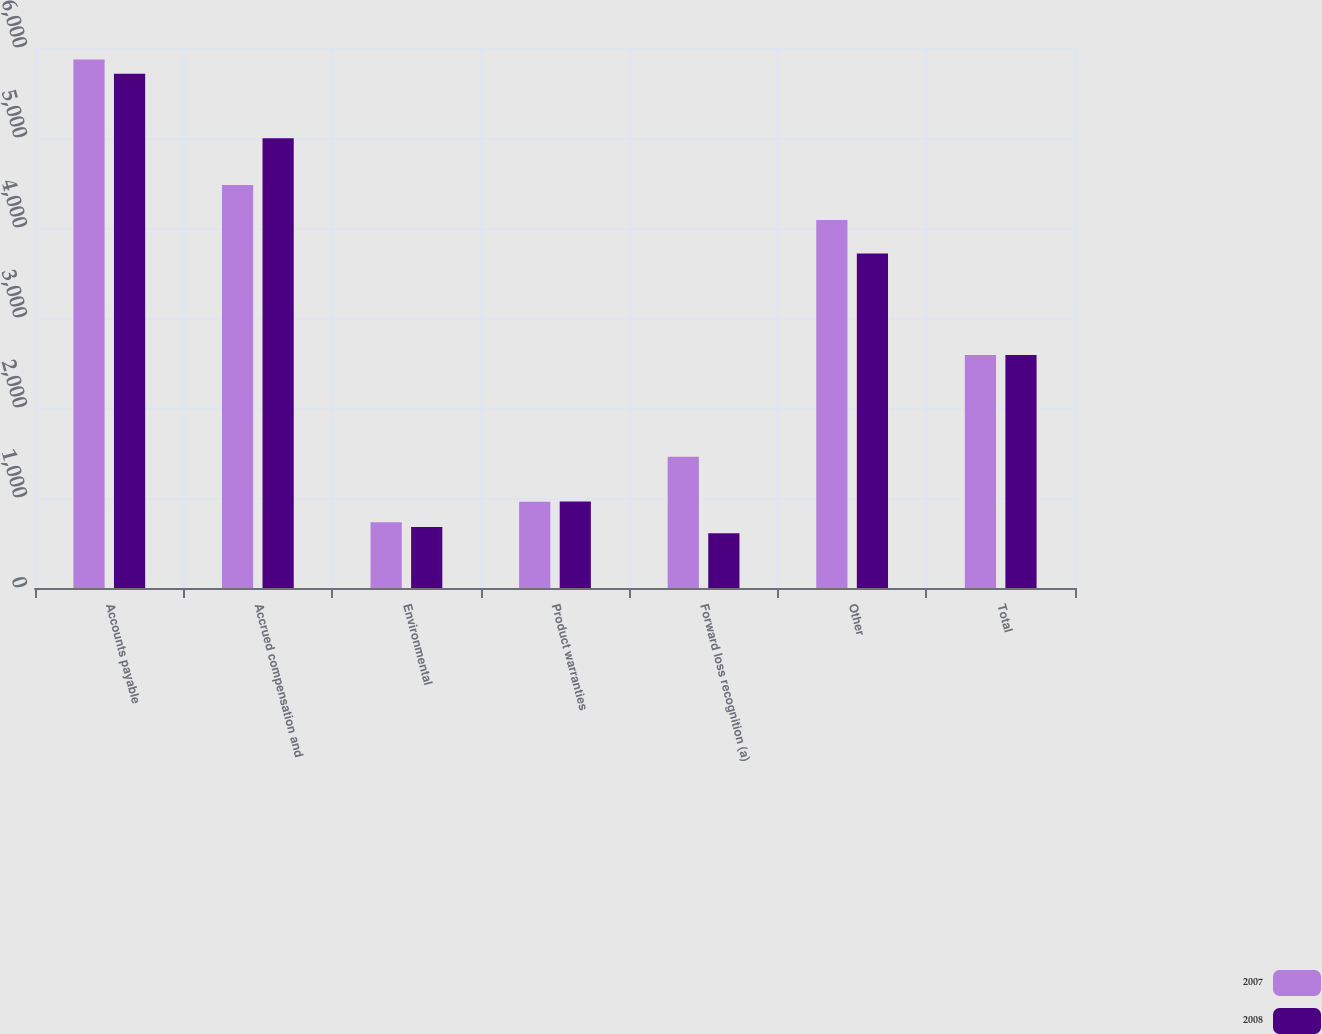Convert chart. <chart><loc_0><loc_0><loc_500><loc_500><stacked_bar_chart><ecel><fcel>Accounts payable<fcel>Accrued compensation and<fcel>Environmental<fcel>Product warranties<fcel>Forward loss recognition (a)<fcel>Other<fcel>Total<nl><fcel>2007<fcel>5871<fcel>4479<fcel>731<fcel>959<fcel>1458<fcel>4089<fcel>2588<nl><fcel>2008<fcel>5714<fcel>4996<fcel>679<fcel>962<fcel>607<fcel>3718<fcel>2588<nl></chart> 